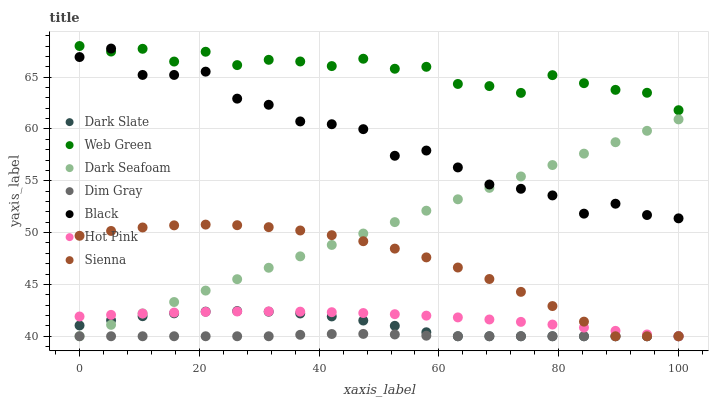Does Dim Gray have the minimum area under the curve?
Answer yes or no. Yes. Does Web Green have the maximum area under the curve?
Answer yes or no. Yes. Does Hot Pink have the minimum area under the curve?
Answer yes or no. No. Does Hot Pink have the maximum area under the curve?
Answer yes or no. No. Is Dark Seafoam the smoothest?
Answer yes or no. Yes. Is Black the roughest?
Answer yes or no. Yes. Is Hot Pink the smoothest?
Answer yes or no. No. Is Hot Pink the roughest?
Answer yes or no. No. Does Dim Gray have the lowest value?
Answer yes or no. Yes. Does Web Green have the lowest value?
Answer yes or no. No. Does Web Green have the highest value?
Answer yes or no. Yes. Does Hot Pink have the highest value?
Answer yes or no. No. Is Dim Gray less than Black?
Answer yes or no. Yes. Is Web Green greater than Dark Slate?
Answer yes or no. Yes. Does Dim Gray intersect Dark Seafoam?
Answer yes or no. Yes. Is Dim Gray less than Dark Seafoam?
Answer yes or no. No. Is Dim Gray greater than Dark Seafoam?
Answer yes or no. No. Does Dim Gray intersect Black?
Answer yes or no. No. 